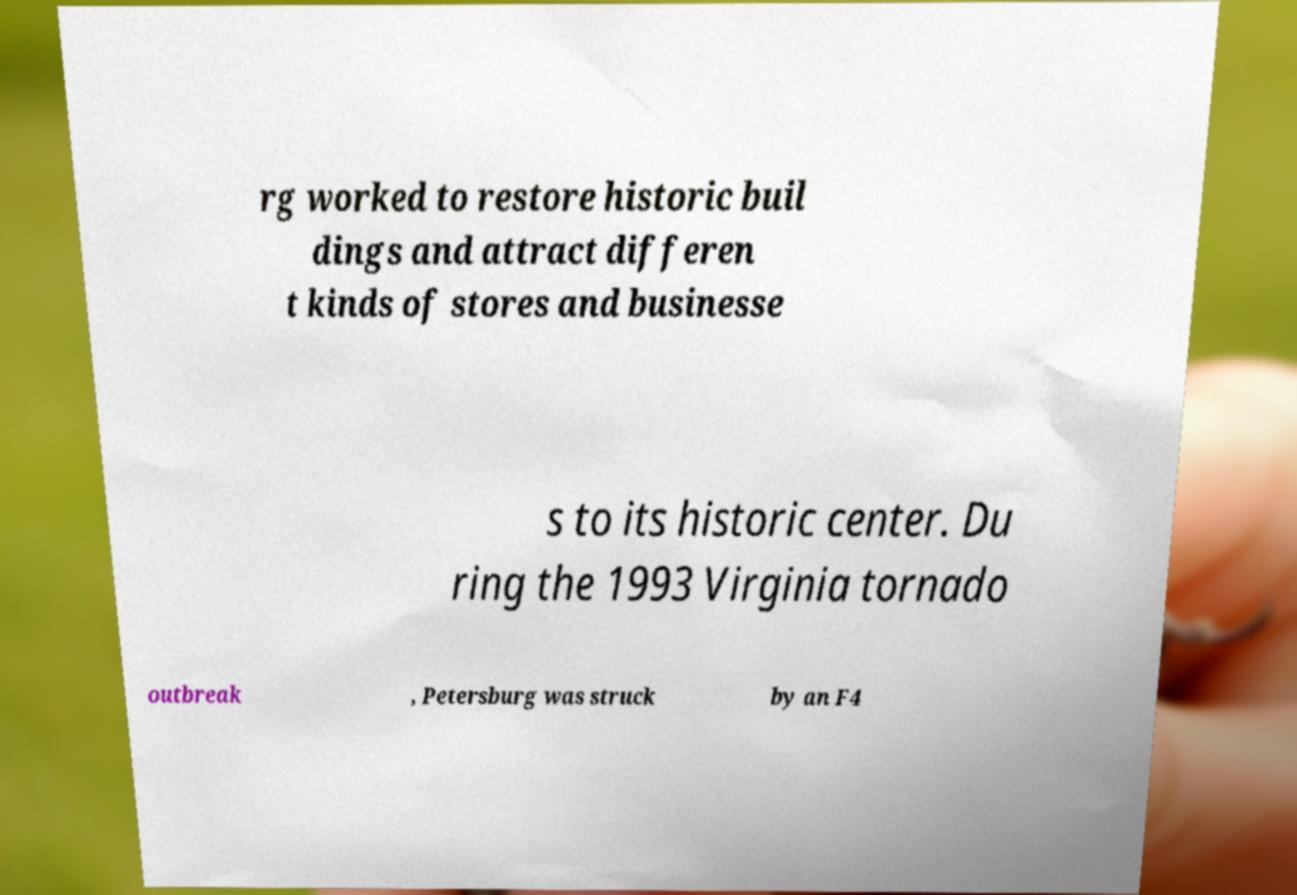Could you assist in decoding the text presented in this image and type it out clearly? rg worked to restore historic buil dings and attract differen t kinds of stores and businesse s to its historic center. Du ring the 1993 Virginia tornado outbreak , Petersburg was struck by an F4 